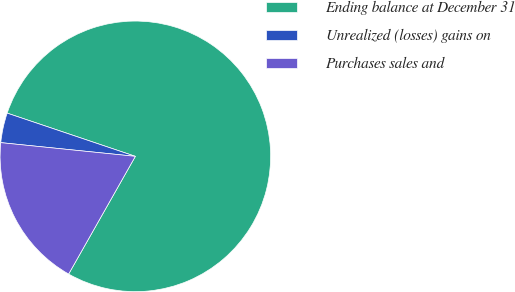<chart> <loc_0><loc_0><loc_500><loc_500><pie_chart><fcel>Ending balance at December 31<fcel>Unrealized (losses) gains on<fcel>Purchases sales and<nl><fcel>78.03%<fcel>3.56%<fcel>18.41%<nl></chart> 